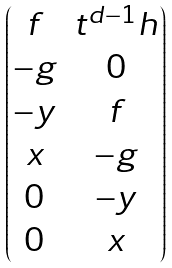<formula> <loc_0><loc_0><loc_500><loc_500>\begin{pmatrix} f & t ^ { d - 1 } h \\ { - g } & 0 \\ { - y } & f \\ x & { - g } \\ 0 & { - y } \\ 0 & x \\ \end{pmatrix}</formula> 